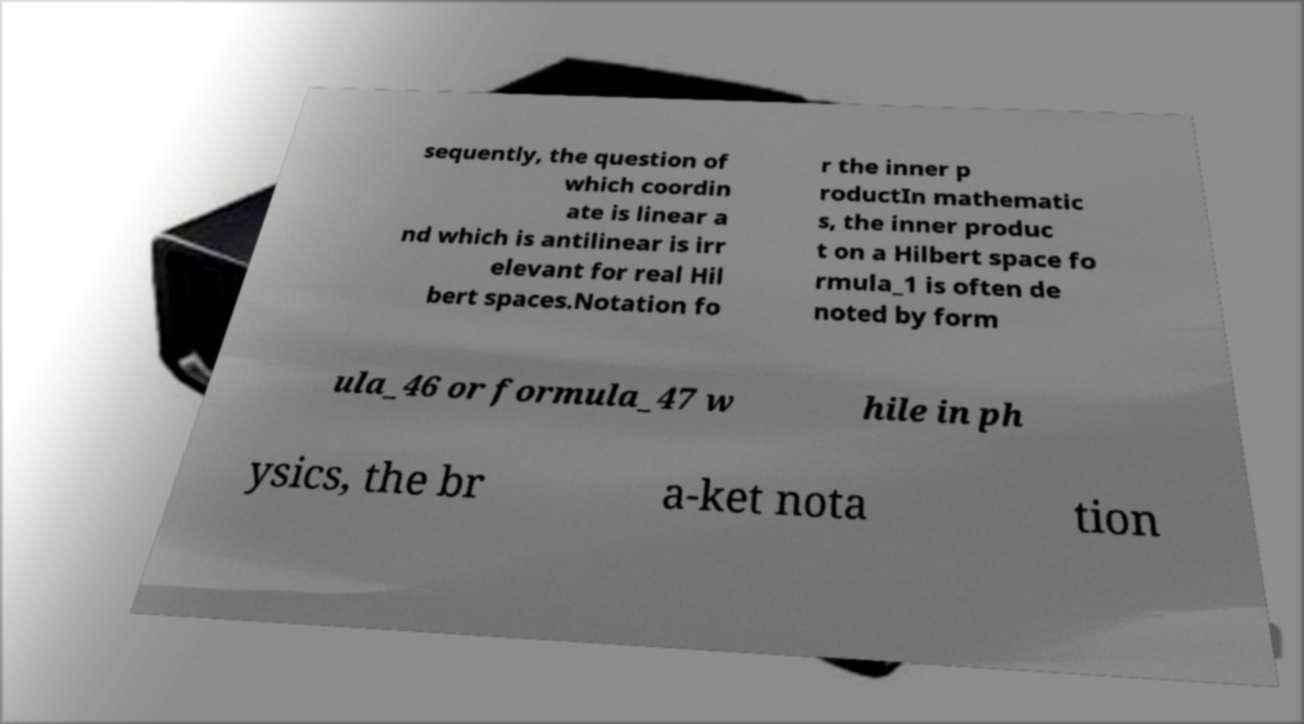I need the written content from this picture converted into text. Can you do that? sequently, the question of which coordin ate is linear a nd which is antilinear is irr elevant for real Hil bert spaces.Notation fo r the inner p roductIn mathematic s, the inner produc t on a Hilbert space fo rmula_1 is often de noted by form ula_46 or formula_47 w hile in ph ysics, the br a-ket nota tion 